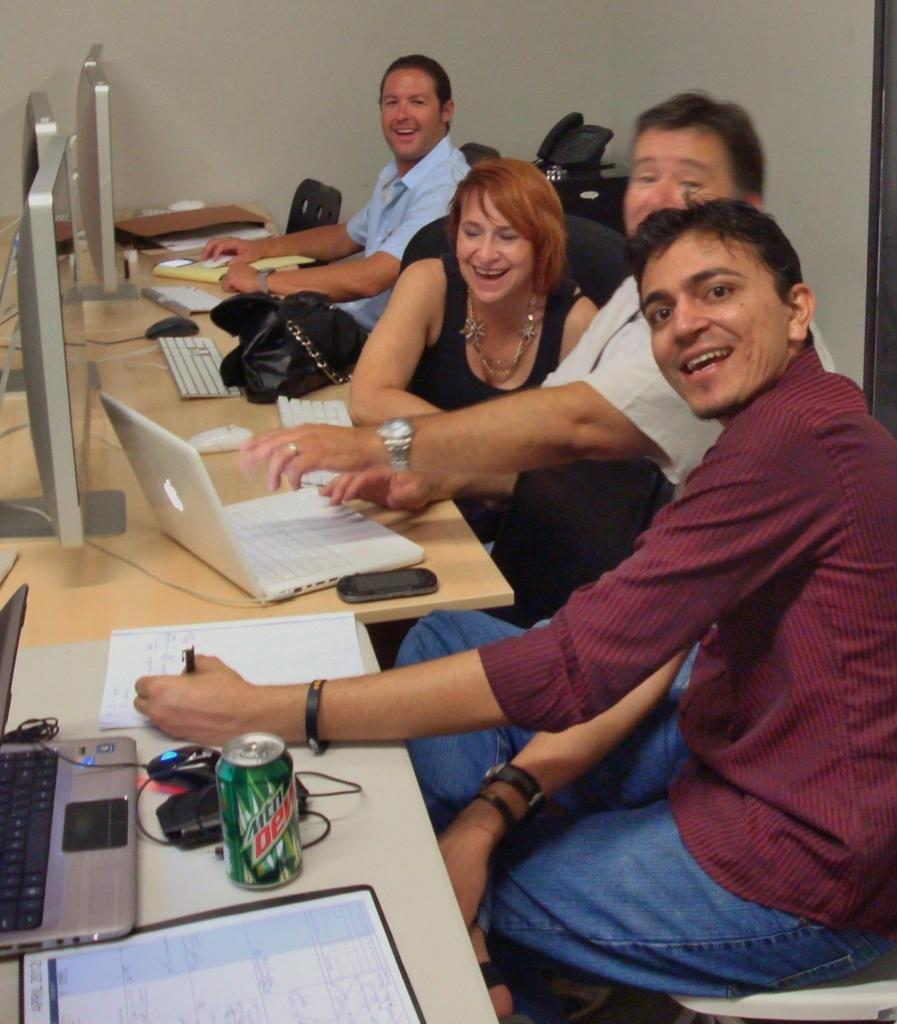What type of furniture can be seen in the image? There are tables and chairs in the image. What electronic devices are visible in the image? Laptops, screens, keyboards, mouses, and a microphone are visible in the image. What items might people use to carry their belongings in the image? Bags are visible in the image. What type of surface might people use to write or draw in the image? Paper is present in the image. How many people are in the image? People are in the image. What type of car is parked in front of the building in the image? There is no car present in the image; it only shows tables, screens, laptops, keyboards, mouses, bags, chairs, a microphone, paper, and people. What type of wood is used to make the chairs in the image? There is no information about the material used to make the chairs in the image. 